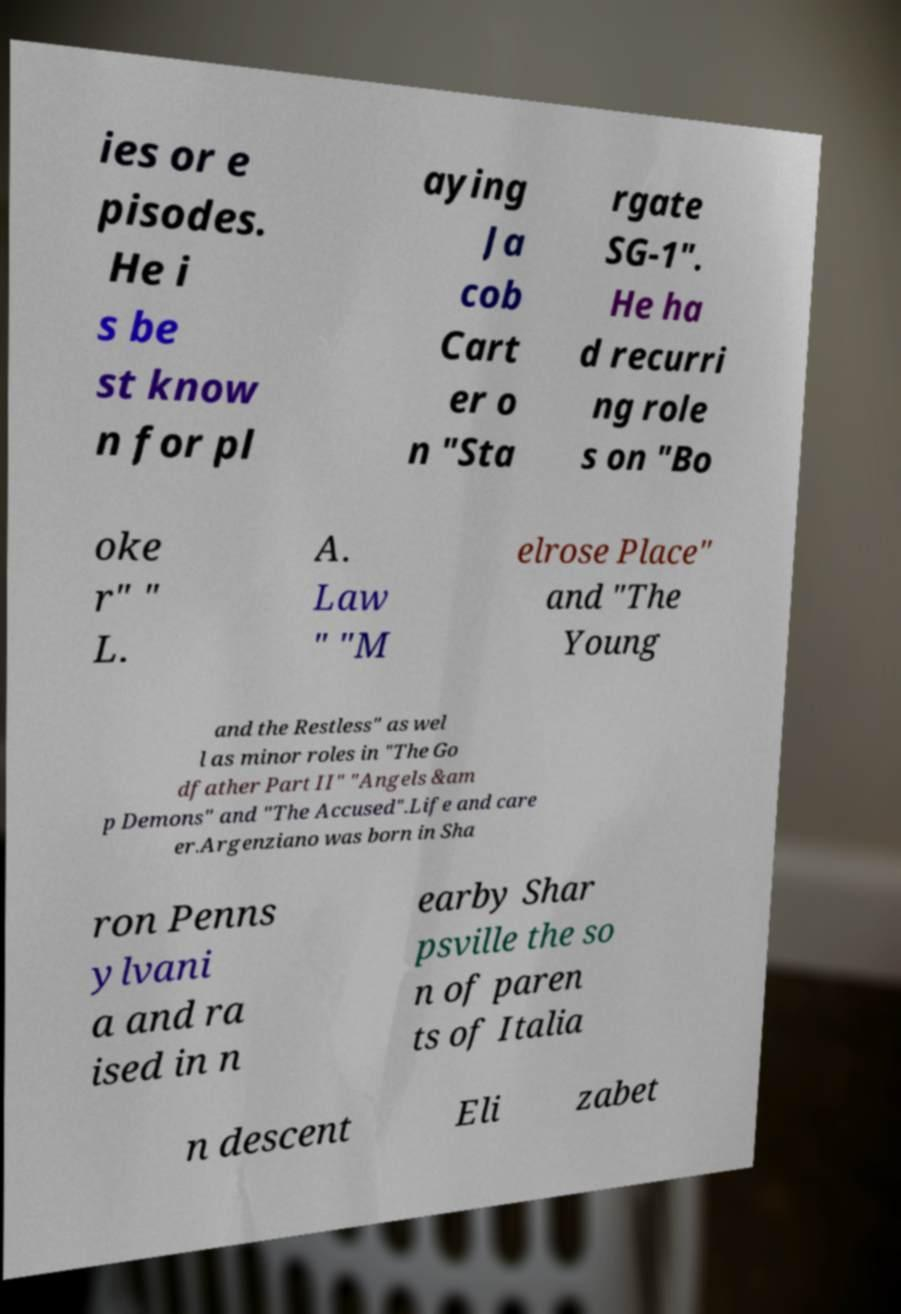Could you extract and type out the text from this image? ies or e pisodes. He i s be st know n for pl aying Ja cob Cart er o n "Sta rgate SG-1". He ha d recurri ng role s on "Bo oke r" " L. A. Law " "M elrose Place" and "The Young and the Restless" as wel l as minor roles in "The Go dfather Part II" "Angels &am p Demons" and "The Accused".Life and care er.Argenziano was born in Sha ron Penns ylvani a and ra ised in n earby Shar psville the so n of paren ts of Italia n descent Eli zabet 